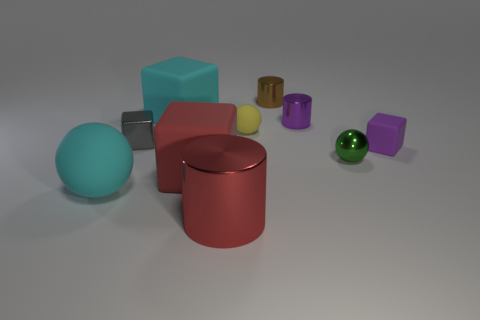Do the large sphere and the small matte sphere have the same color?
Offer a very short reply. No. Are there any other things that are the same shape as the tiny gray object?
Offer a terse response. Yes. Are there fewer big cyan rubber balls than large cyan matte cylinders?
Your response must be concise. No. There is a metallic cylinder in front of the small cube that is on the left side of the yellow rubber ball; what color is it?
Offer a terse response. Red. There is a gray cube on the left side of the large rubber object behind the tiny metallic object in front of the gray object; what is its material?
Make the answer very short. Metal. Does the block that is to the right of the red metallic thing have the same size as the red block?
Your response must be concise. No. There is a purple object behind the tiny purple cube; what material is it?
Your answer should be compact. Metal. Is the number of big cyan matte spheres greater than the number of matte balls?
Offer a terse response. No. What number of things are big things behind the large metallic cylinder or tiny yellow things?
Your response must be concise. 4. There is a metal cylinder in front of the tiny yellow ball; what number of gray metallic blocks are behind it?
Give a very brief answer. 1. 